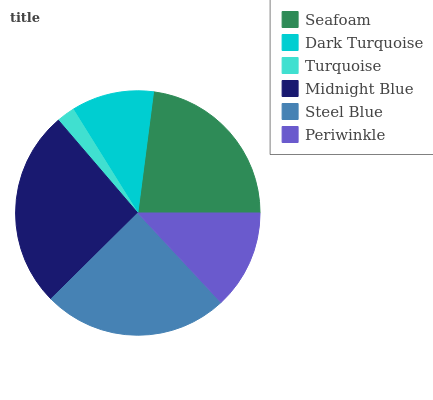Is Turquoise the minimum?
Answer yes or no. Yes. Is Midnight Blue the maximum?
Answer yes or no. Yes. Is Dark Turquoise the minimum?
Answer yes or no. No. Is Dark Turquoise the maximum?
Answer yes or no. No. Is Seafoam greater than Dark Turquoise?
Answer yes or no. Yes. Is Dark Turquoise less than Seafoam?
Answer yes or no. Yes. Is Dark Turquoise greater than Seafoam?
Answer yes or no. No. Is Seafoam less than Dark Turquoise?
Answer yes or no. No. Is Seafoam the high median?
Answer yes or no. Yes. Is Periwinkle the low median?
Answer yes or no. Yes. Is Turquoise the high median?
Answer yes or no. No. Is Steel Blue the low median?
Answer yes or no. No. 